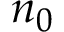<formula> <loc_0><loc_0><loc_500><loc_500>n _ { 0 }</formula> 